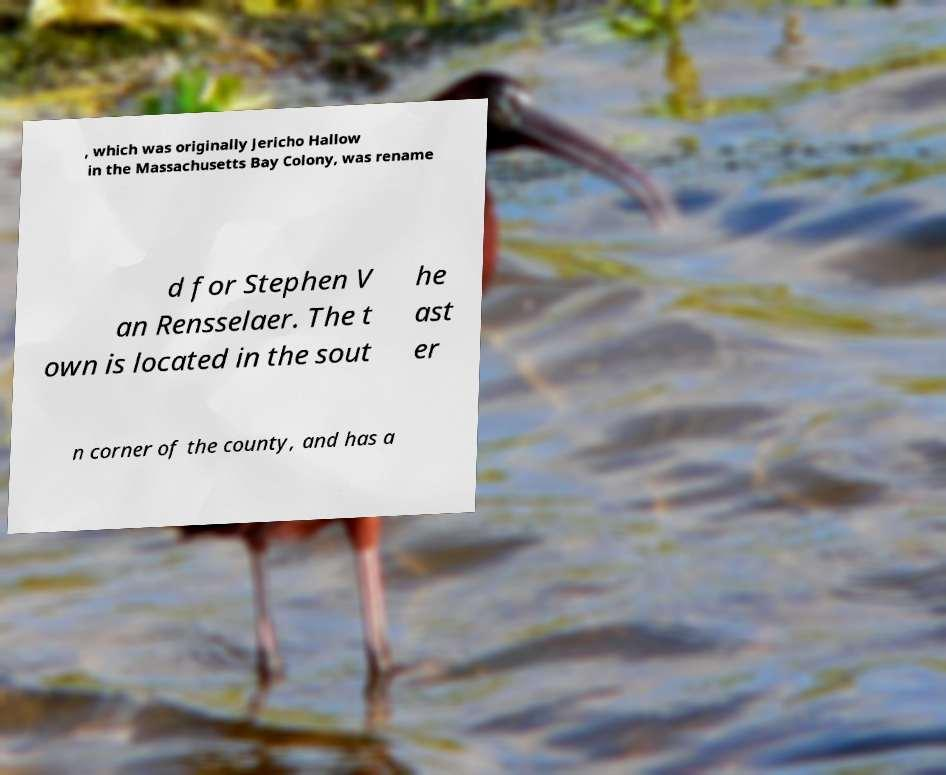What messages or text are displayed in this image? I need them in a readable, typed format. , which was originally Jericho Hallow in the Massachusetts Bay Colony, was rename d for Stephen V an Rensselaer. The t own is located in the sout he ast er n corner of the county, and has a 